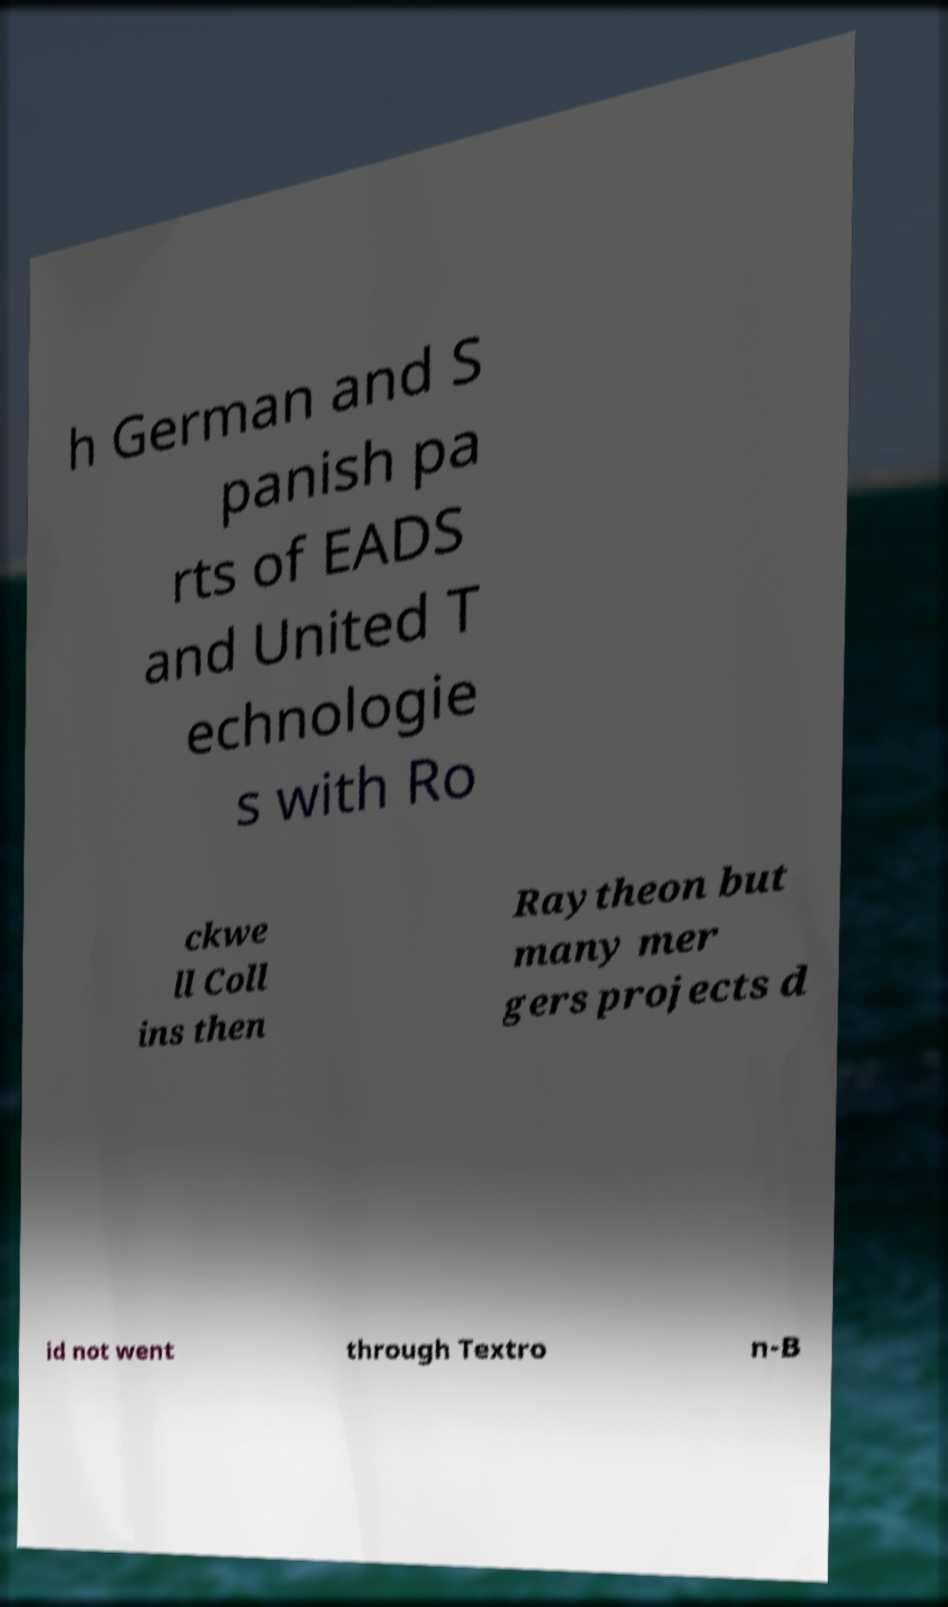Could you assist in decoding the text presented in this image and type it out clearly? h German and S panish pa rts of EADS and United T echnologie s with Ro ckwe ll Coll ins then Raytheon but many mer gers projects d id not went through Textro n-B 